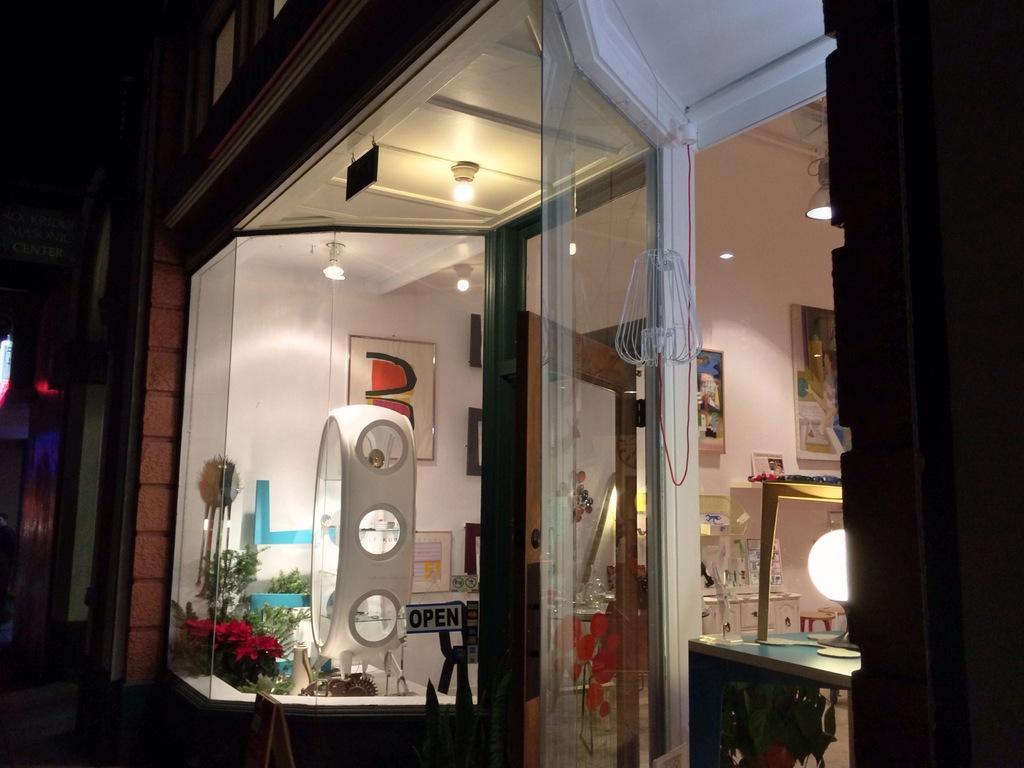Could you give a brief overview of what you see in this image? In the picture I can see framed glass wall, a glass door, photo frames attached to the wall, lights on the ceiling and some other objects. The background of the image is dark. 